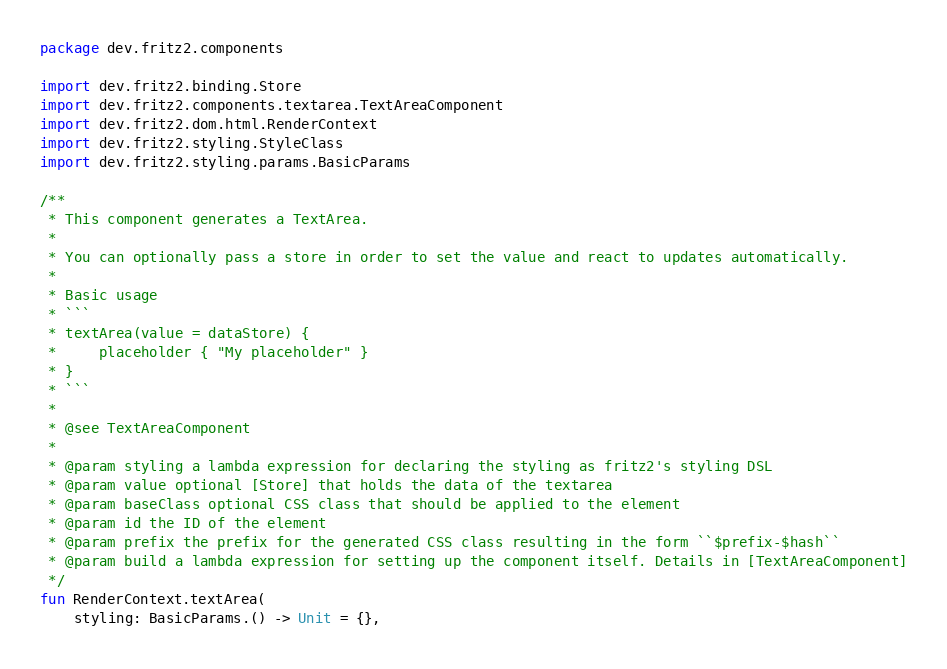<code> <loc_0><loc_0><loc_500><loc_500><_Kotlin_>package dev.fritz2.components

import dev.fritz2.binding.Store
import dev.fritz2.components.textarea.TextAreaComponent
import dev.fritz2.dom.html.RenderContext
import dev.fritz2.styling.StyleClass
import dev.fritz2.styling.params.BasicParams

/**
 * This component generates a TextArea.
 *
 * You can optionally pass a store in order to set the value and react to updates automatically.
 *
 * Basic usage
 * ```
 * textArea(value = dataStore) {
 *     placeholder { "My placeholder" }
 * }
 * ```
 *
 * @see TextAreaComponent
 *
 * @param styling a lambda expression for declaring the styling as fritz2's styling DSL
 * @param value optional [Store] that holds the data of the textarea
 * @param baseClass optional CSS class that should be applied to the element
 * @param id the ID of the element
 * @param prefix the prefix for the generated CSS class resulting in the form ``$prefix-$hash``
 * @param build a lambda expression for setting up the component itself. Details in [TextAreaComponent]
 */
fun RenderContext.textArea(
    styling: BasicParams.() -> Unit = {},</code> 